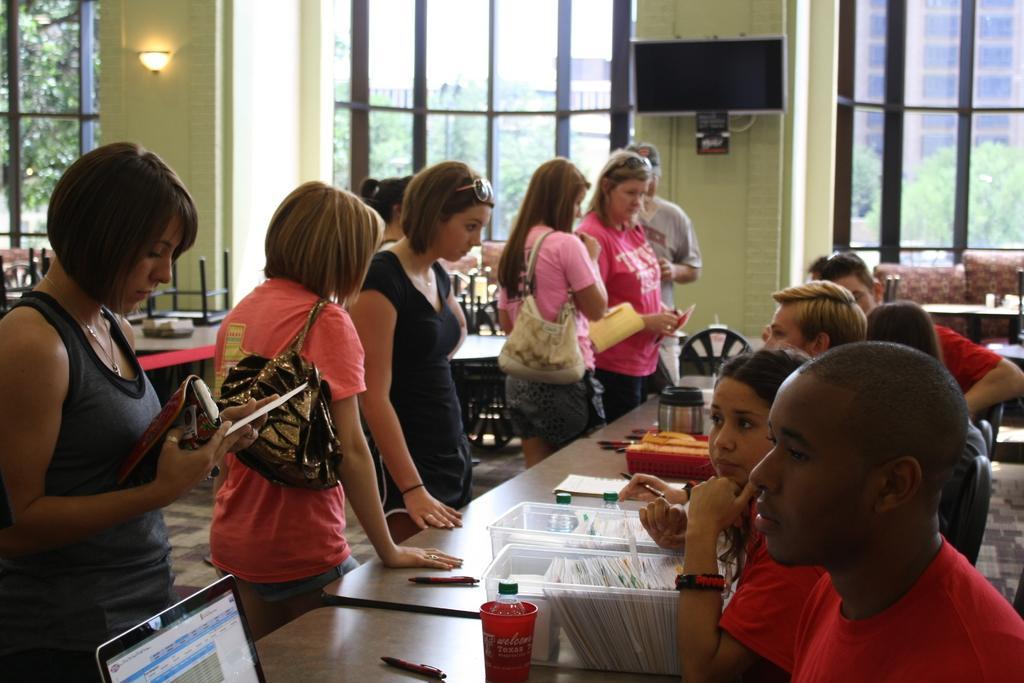Can you describe this image briefly? It is a room there are some people sitting in front of the table and on the other side some people are standing and there is a laptop, cup, and some boxes on the table behind the people who are standing there are also some other tables and chairs in the background there is a television to the wall and window beside it outside the window there is a building, trees and sky. 